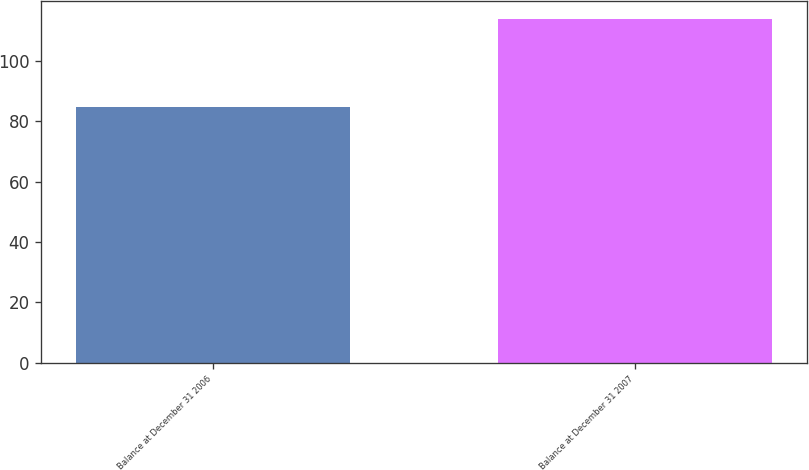Convert chart. <chart><loc_0><loc_0><loc_500><loc_500><bar_chart><fcel>Balance at December 31 2006<fcel>Balance at December 31 2007<nl><fcel>84.7<fcel>114.1<nl></chart> 